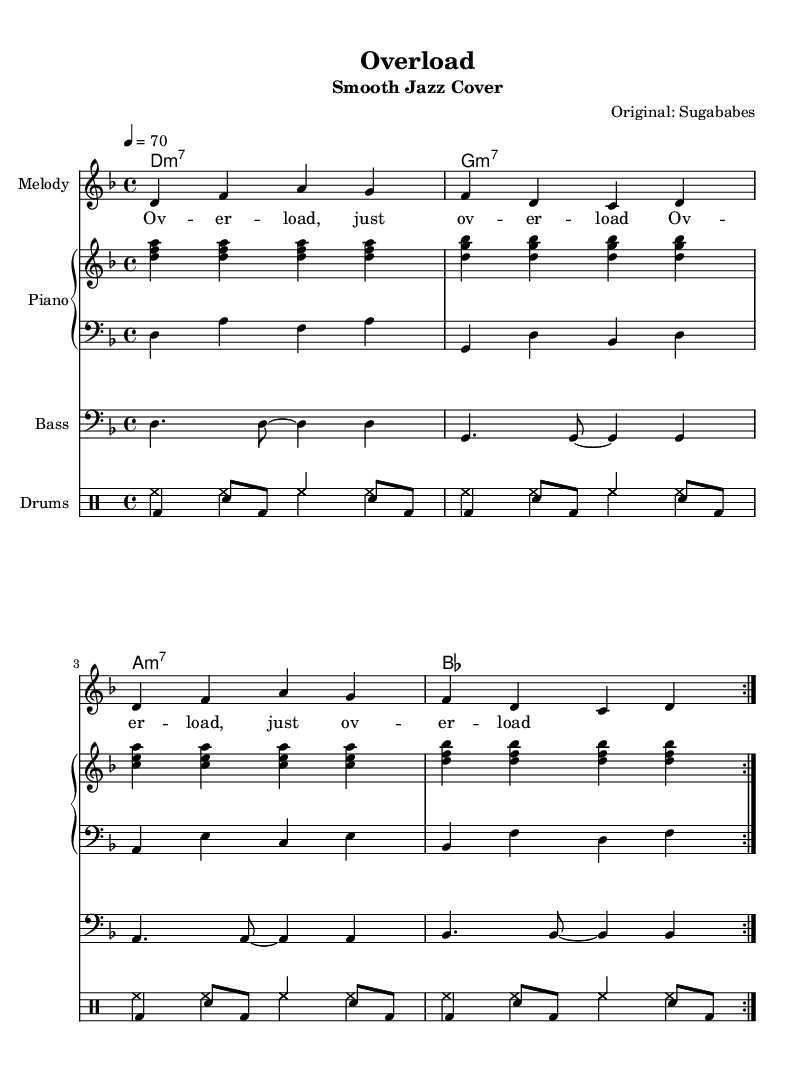What is the key signature of this music? The key signature is D minor, which has one flat (B flat). The key signature indicated at the beginning shows the D minor scale as the fundamental tonal center.
Answer: D minor What is the time signature of this music? The time signature shown in the music is 4/4, which means there are four beats in each measure and the quarter note receives one beat.
Answer: 4/4 What is the tempo marking for this piece? The tempo marking at the beginning states that the piece should be played at a tempo of 70 beats per minute, indicating a slow and relaxed feel typical of smooth jazz.
Answer: 70 How many measures are repeated in the piece? The piece has a repeat sign indicating that the section is to be played twice (volta 2), which is specified in the chord and melody sections.
Answer: 2 What instrument plays the melody in this arrangement? The arrangement indicates that the 'Melody' staff plays the main vocal line, which is typically sung but represented here for an instrument.
Answer: Melody What type of chords are predominantly used in this piece? The chords mostly consist of minor seventh chords, which create a smooth, jazzy sound, characteristic of the genre and are evident in the chord names of the sheet music.
Answer: Minor seventh 